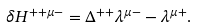Convert formula to latex. <formula><loc_0><loc_0><loc_500><loc_500>\delta H ^ { + + \mu - } = \Delta ^ { + + } \lambda ^ { \mu - } - \lambda ^ { \mu + } .</formula> 